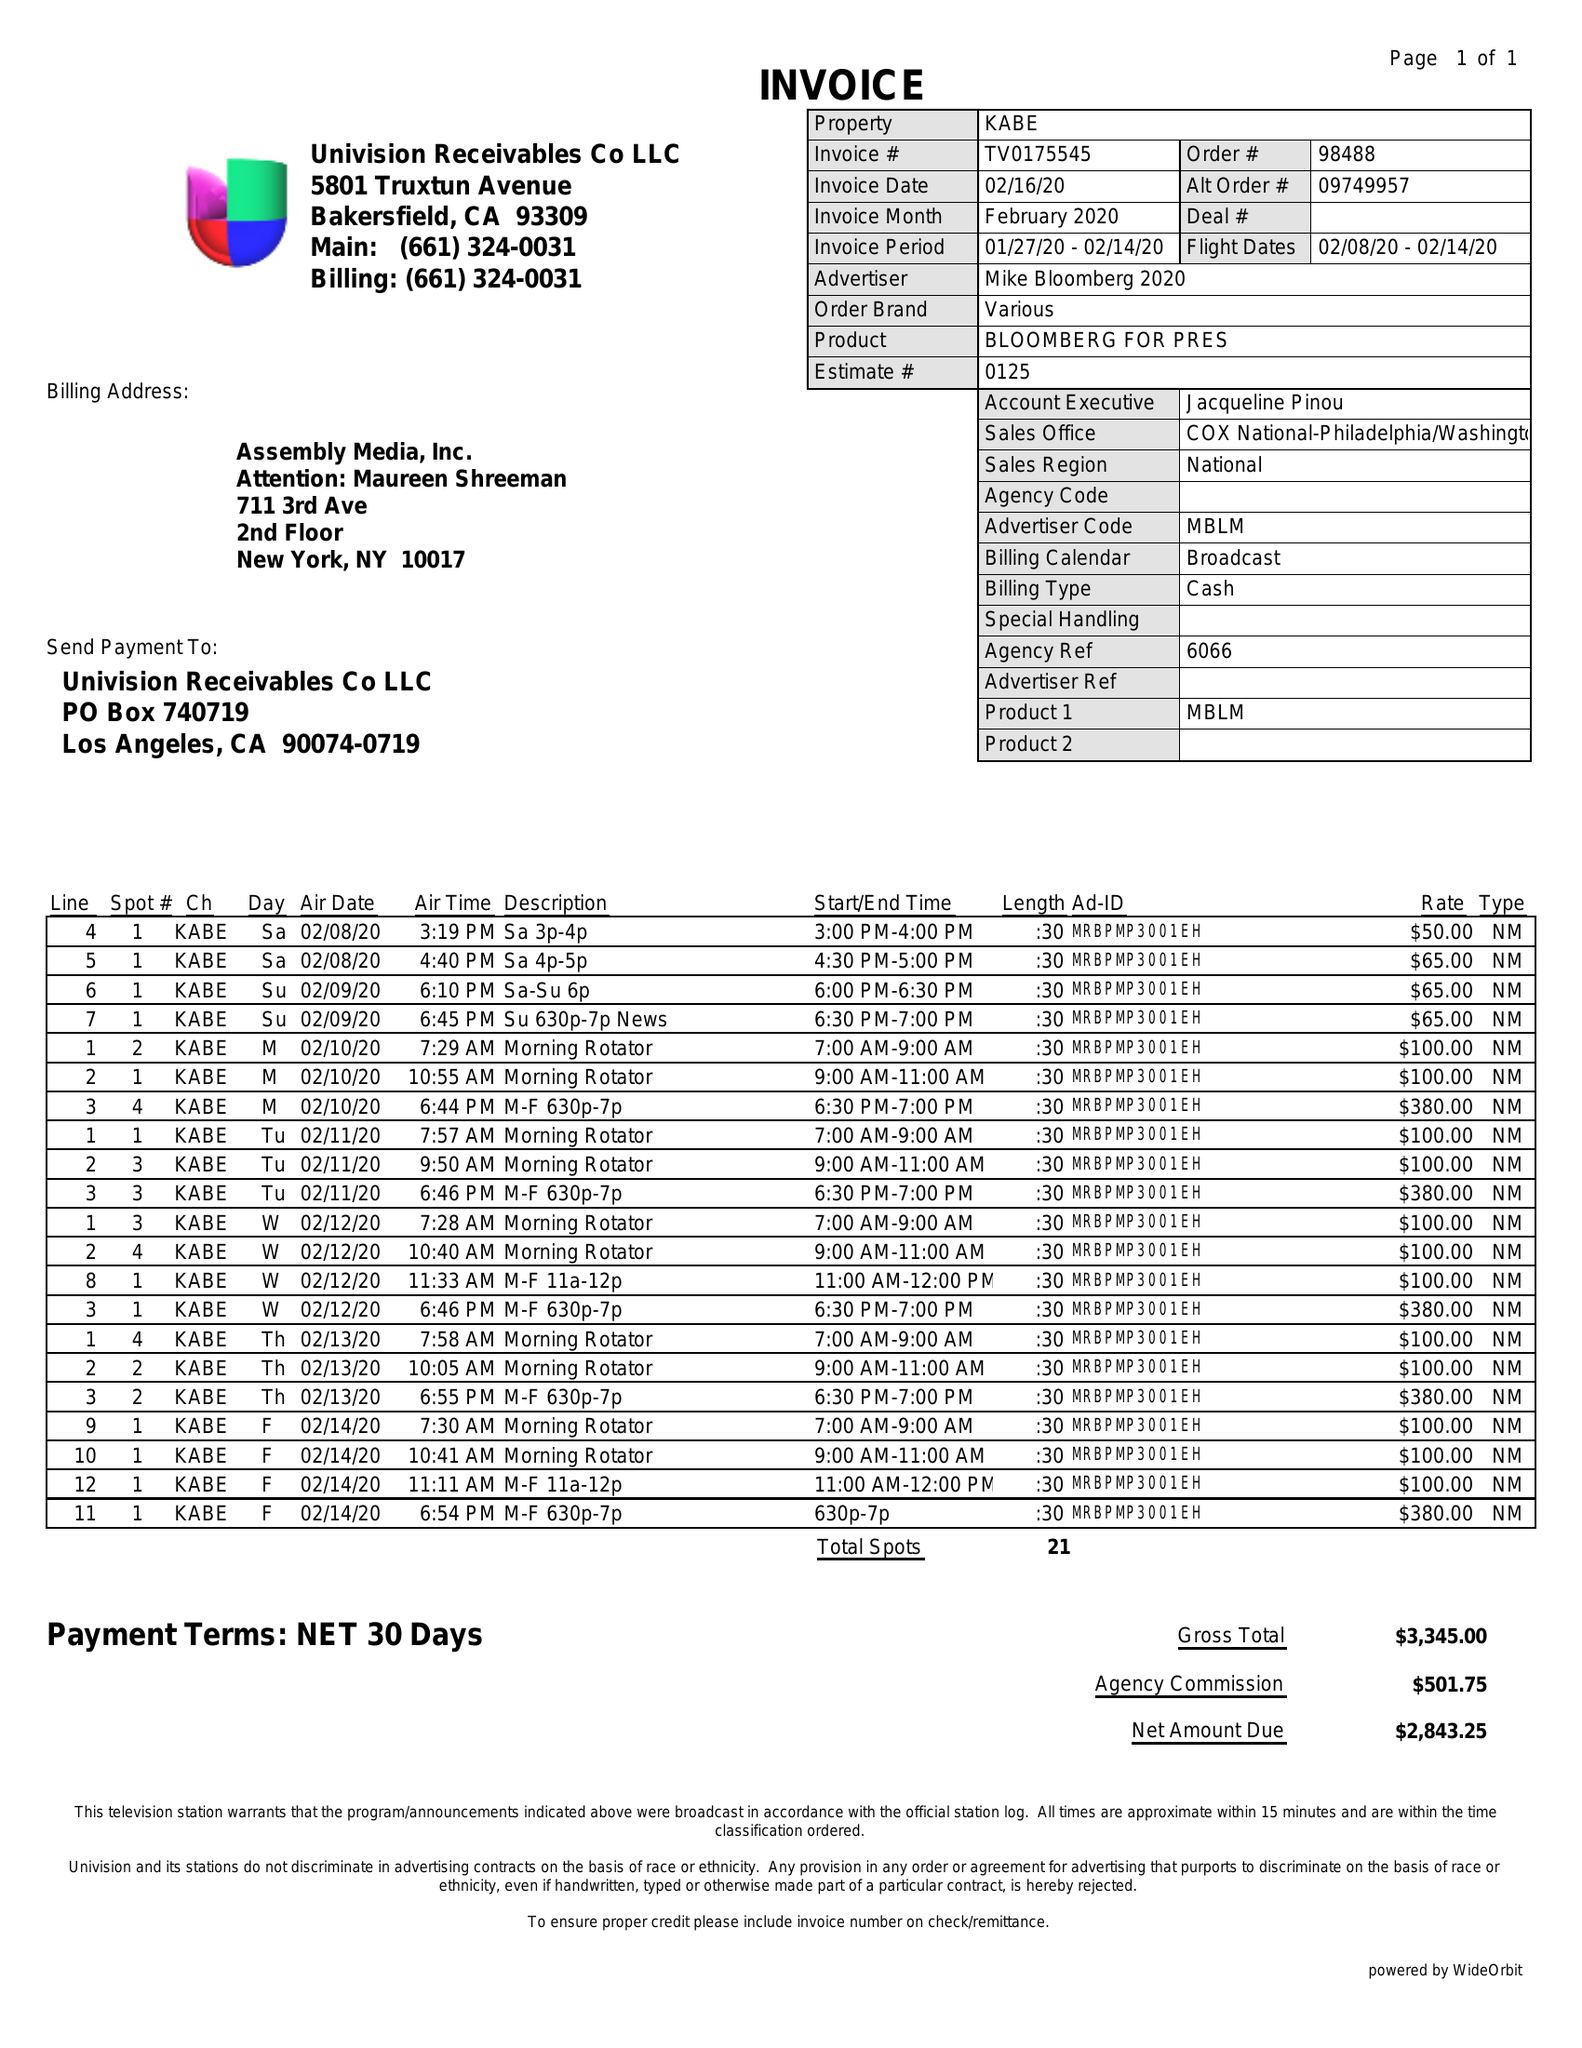What is the value for the gross_amount?
Answer the question using a single word or phrase. 3345.00 